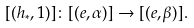Convert formula to latex. <formula><loc_0><loc_0><loc_500><loc_500>[ ( h _ { \ast } , 1 ) ] \colon [ ( e , \alpha ) ] \to [ ( e , \beta ) ] .</formula> 